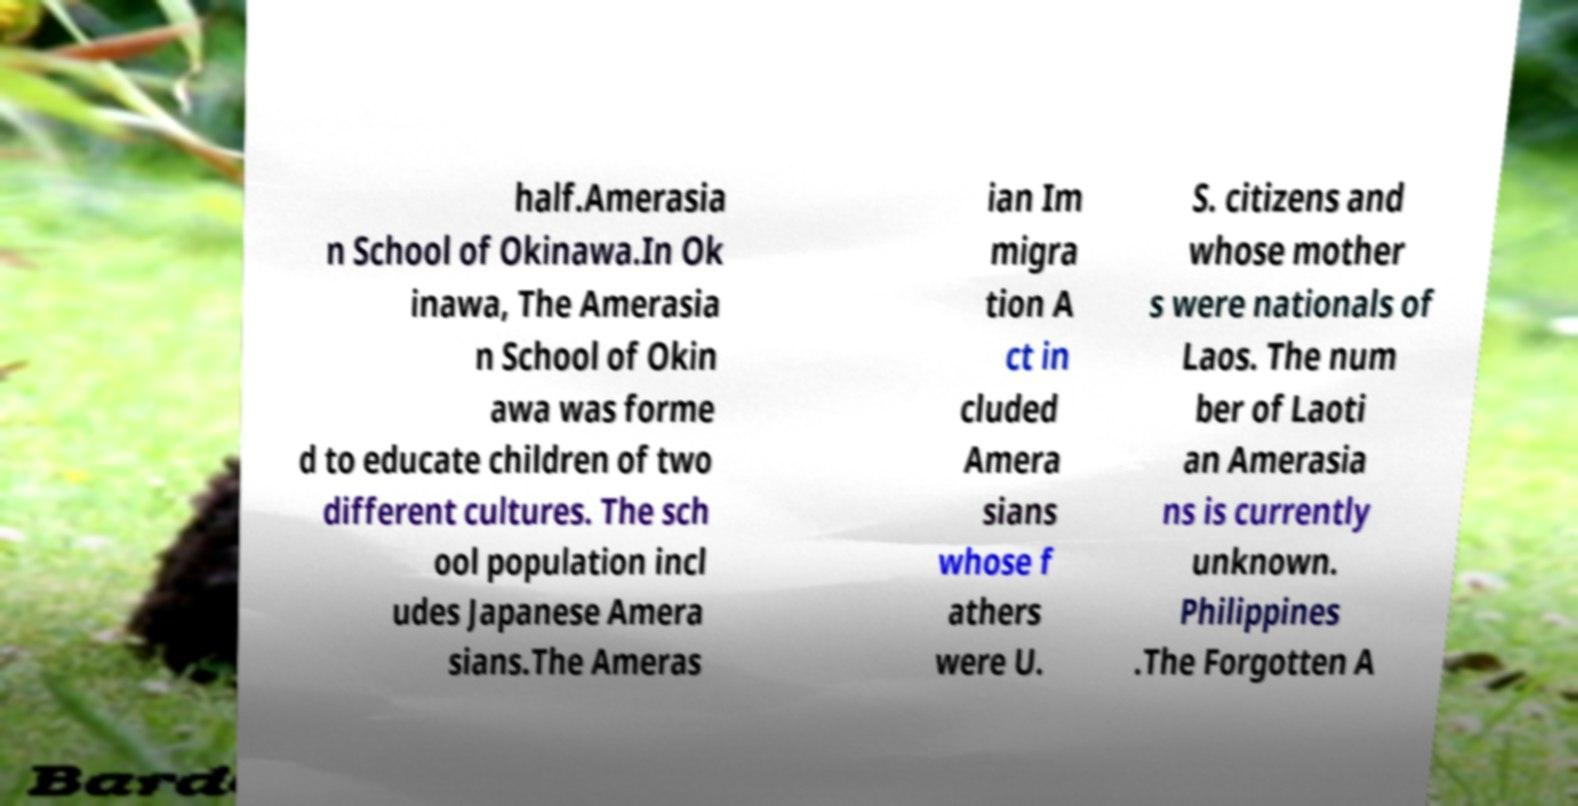There's text embedded in this image that I need extracted. Can you transcribe it verbatim? half.Amerasia n School of Okinawa.In Ok inawa, The Amerasia n School of Okin awa was forme d to educate children of two different cultures. The sch ool population incl udes Japanese Amera sians.The Ameras ian Im migra tion A ct in cluded Amera sians whose f athers were U. S. citizens and whose mother s were nationals of Laos. The num ber of Laoti an Amerasia ns is currently unknown. Philippines .The Forgotten A 